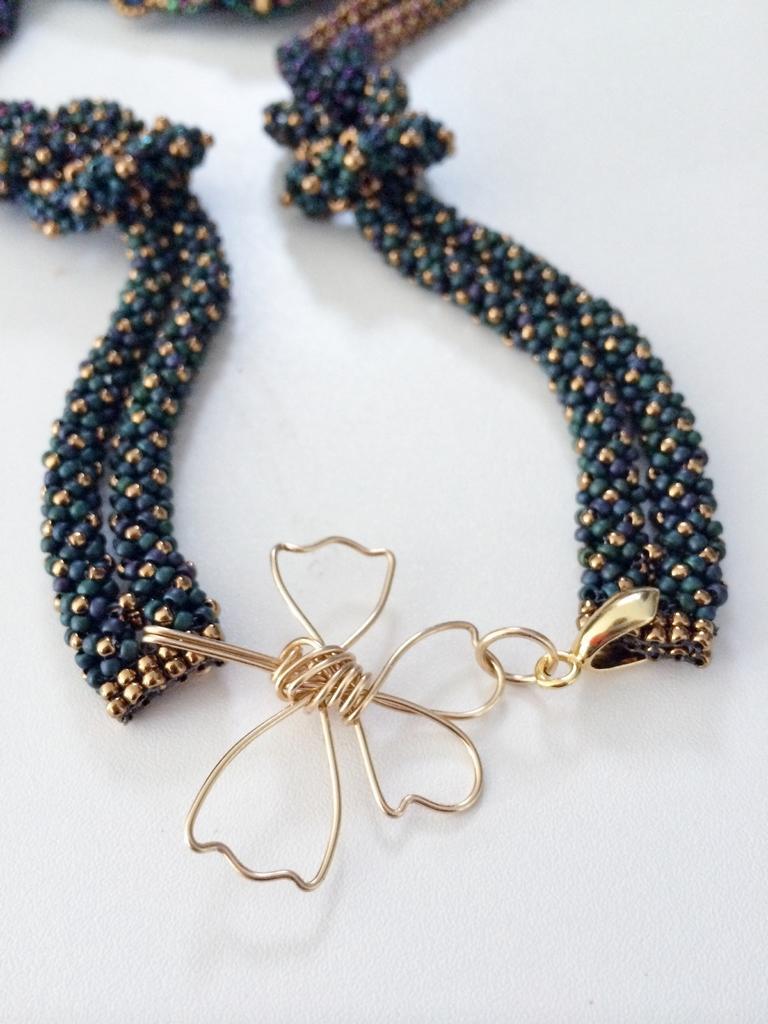How would you summarize this image in a sentence or two? In this image I can see the accessory in blue and gold color. It is on white color surface. 